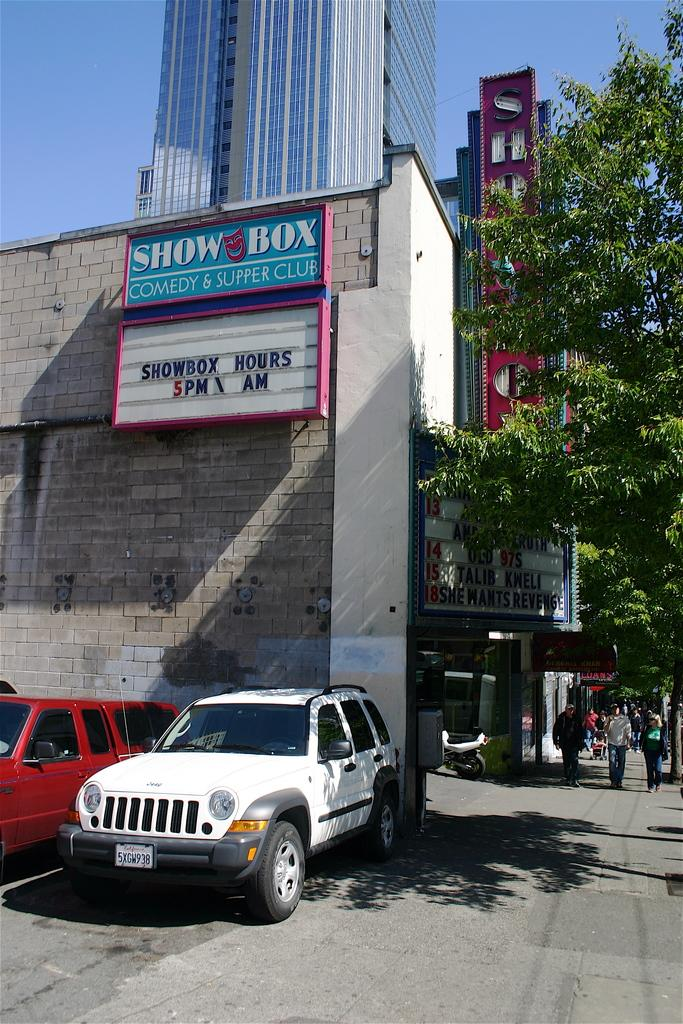Provide a one-sentence caption for the provided image. The Show Box comedy and supper club opens at 5 pm according to their sign. 